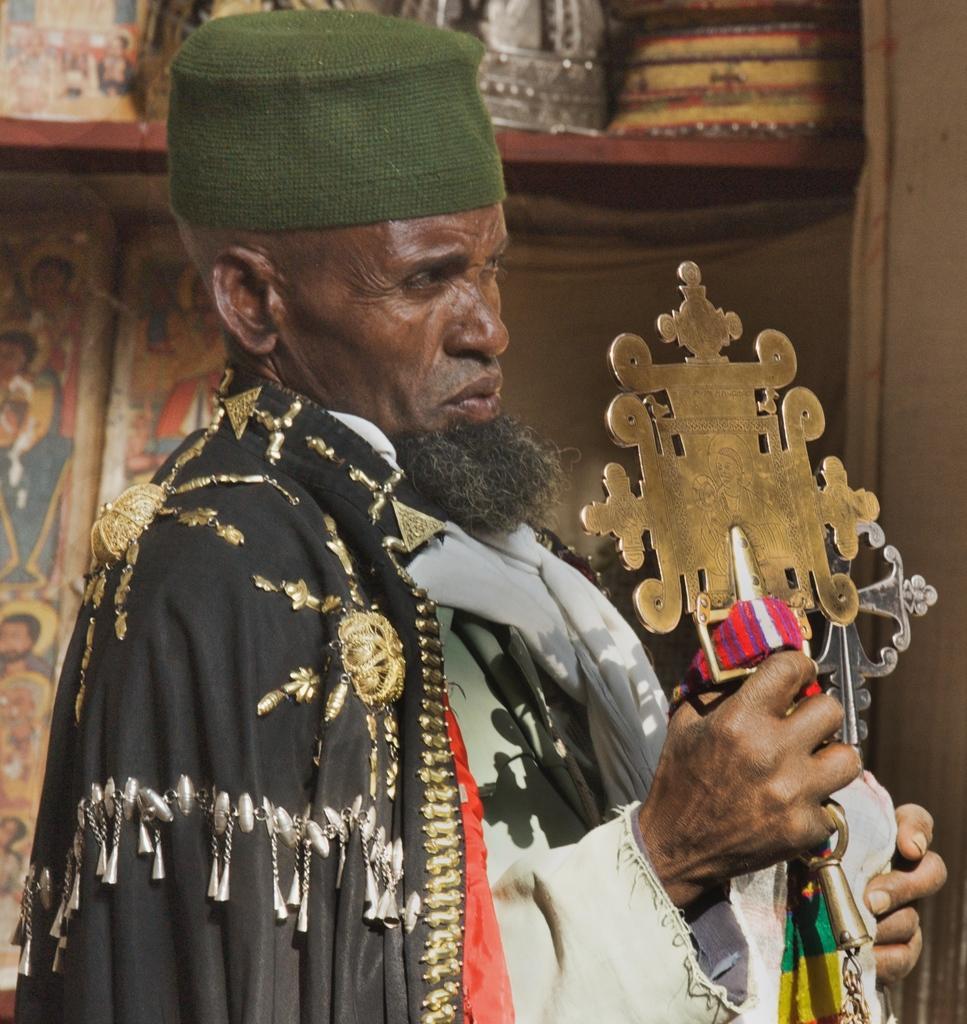Can you describe this image briefly? In the center of the image we can see a person is standing and he is holding some objects. And we can see he is in a different costume and he is wearing a hat. In the background there is a wall and a few other objects. 